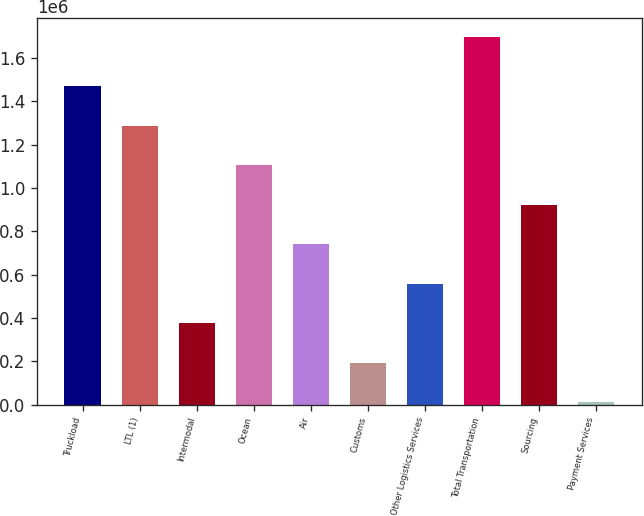<chart> <loc_0><loc_0><loc_500><loc_500><bar_chart><fcel>Truckload<fcel>LTL (1)<fcel>Intermodal<fcel>Ocean<fcel>Air<fcel>Customs<fcel>Other Logistics Services<fcel>Total Transportation<fcel>Sourcing<fcel>Payment Services<nl><fcel>1.47103e+06<fcel>1.28849e+06<fcel>375819<fcel>1.10596e+06<fcel>740888<fcel>193284<fcel>558354<fcel>1.6984e+06<fcel>923422<fcel>10750<nl></chart> 